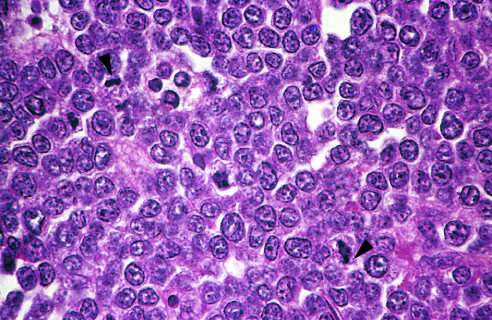re normal macrophages better appreciated at a lower magnification?
Answer the question using a single word or phrase. Yes 